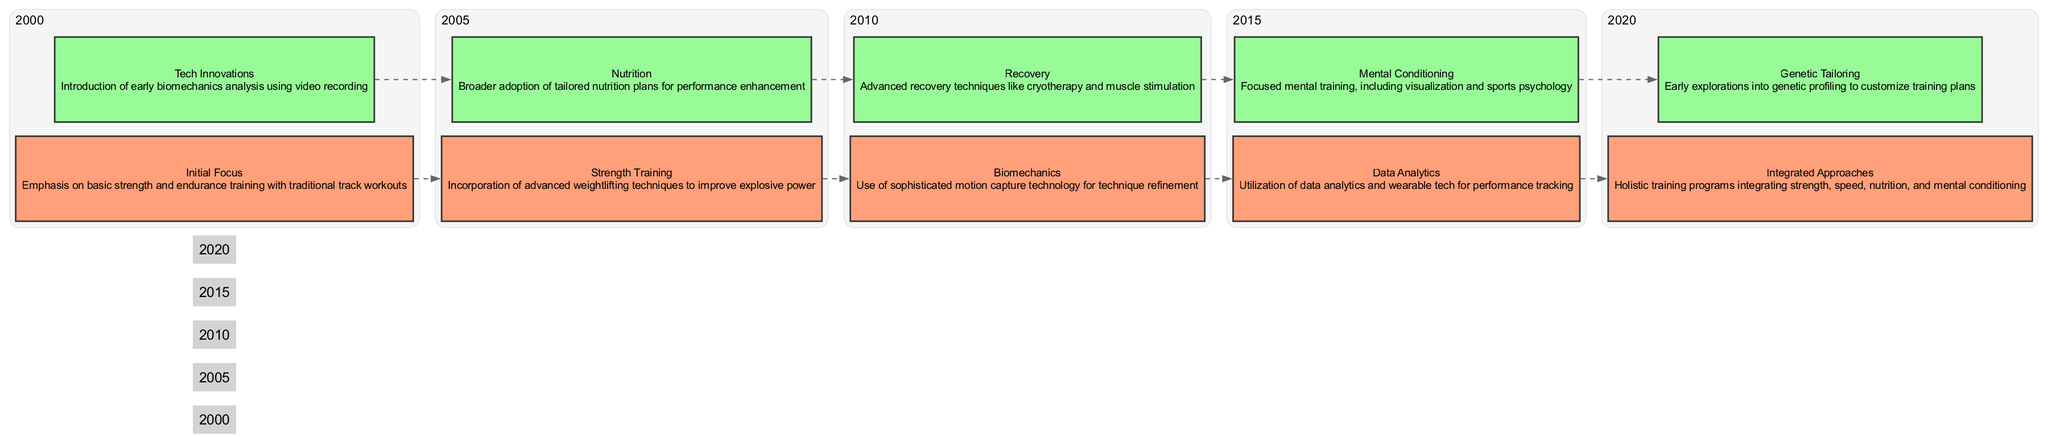What is the main focus of training techniques in 2000? In 2000, the diagram highlights "Initial Focus," which emphasizes basic strength and endurance training alongside traditional track workouts. This indicates that the core focus was on foundational physical attributes for sprinting.
Answer: Initial Focus How many elements are listed for the year 2010? For the year 2010, the diagram shows two elements: Biomechanics and Recovery. This direct observation from the nodes indicates the number of elements for that year.
Answer: 2 What advanced technique was introduced in 2005? The diagram describes that in 2005, the incorporation of "advanced weightlifting techniques" was a major focus to enhance explosive power in sprinting. Thus, the specific advanced technique is weightlifting.
Answer: Weightlifting techniques What recovery method was highlighted in 2010? The recovery method highlighted in 2010 is "cryotherapy", which is mentioned in conjunction with advanced recovery techniques in the diagram. This reference points directly to the type of recovery method emphasized that year.
Answer: Cryotherapy What new approach was introduced in 2020? In 2020, the diagram indicates that the main new approach was "Integrated Approaches," which signifies a shift to holistic training combining various elements of conditioning and performance. This shift is a key evolution in training techniques.
Answer: Integrated Approaches Which year introduced the use of data analytics? The diagram clearly states that the year when "Data Analytics" was utilized for performance tracking is 2015. This year marks the incorporation of technology to aid training and performance evaluation, as indicated in the relevant block.
Answer: 2015 What are the two elements associated with the year 2020? The diagram outlines that the two elements for 2020 are "Integrated Approaches" and "Genetic Tailoring." These are clearly listed under the year 2020 in the block, showcasing the advancements made during this time frame.
Answer: Integrated Approaches, Genetic Tailoring In what year did nutrition plans start gaining broader adoption? According to the diagram, 2005 marks the year when broader adoption of "tailored nutrition plans for performance enhancement" began, signifying an important development in the training methodologies of sprinters.
Answer: 2005 How does mental conditioning compare to data analytics chronologically? In the diagram, mental conditioning was highlighted in 2015, the same year when data analytics was introduced. This shows that both techniques were developed contemporaneously, suggesting an overall evolution in training techniques around this period.
Answer: Same year, 2015 